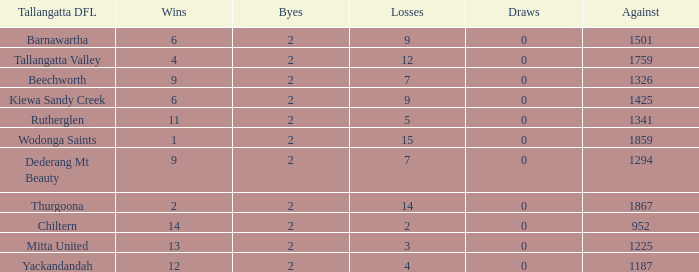Parse the full table. {'header': ['Tallangatta DFL', 'Wins', 'Byes', 'Losses', 'Draws', 'Against'], 'rows': [['Barnawartha', '6', '2', '9', '0', '1501'], ['Tallangatta Valley', '4', '2', '12', '0', '1759'], ['Beechworth', '9', '2', '7', '0', '1326'], ['Kiewa Sandy Creek', '6', '2', '9', '0', '1425'], ['Rutherglen', '11', '2', '5', '0', '1341'], ['Wodonga Saints', '1', '2', '15', '0', '1859'], ['Dederang Mt Beauty', '9', '2', '7', '0', '1294'], ['Thurgoona', '2', '2', '14', '0', '1867'], ['Chiltern', '14', '2', '2', '0', '952'], ['Mitta United', '13', '2', '3', '0', '1225'], ['Yackandandah', '12', '2', '4', '0', '1187']]} What are the draws when wins are fwewer than 9 and byes fewer than 2? 0.0. 